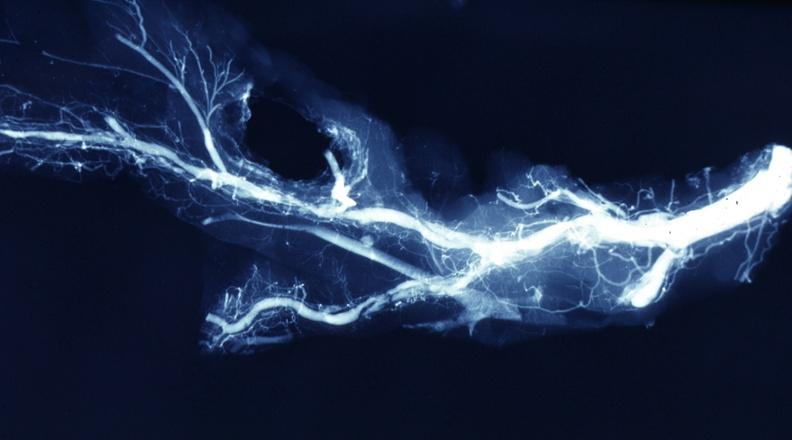does intraductal papillomatosis with apocrine metaplasia show x-ray postmortdissected artery lesions in small branches?
Answer the question using a single word or phrase. No 